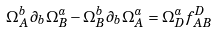Convert formula to latex. <formula><loc_0><loc_0><loc_500><loc_500>\Omega ^ { b } _ { A } \partial _ { b } \Omega ^ { a } _ { B } - \Omega ^ { b } _ { B } \partial _ { b } \Omega ^ { a } _ { A } = \Omega ^ { a } _ { D } f ^ { D } _ { A B }</formula> 